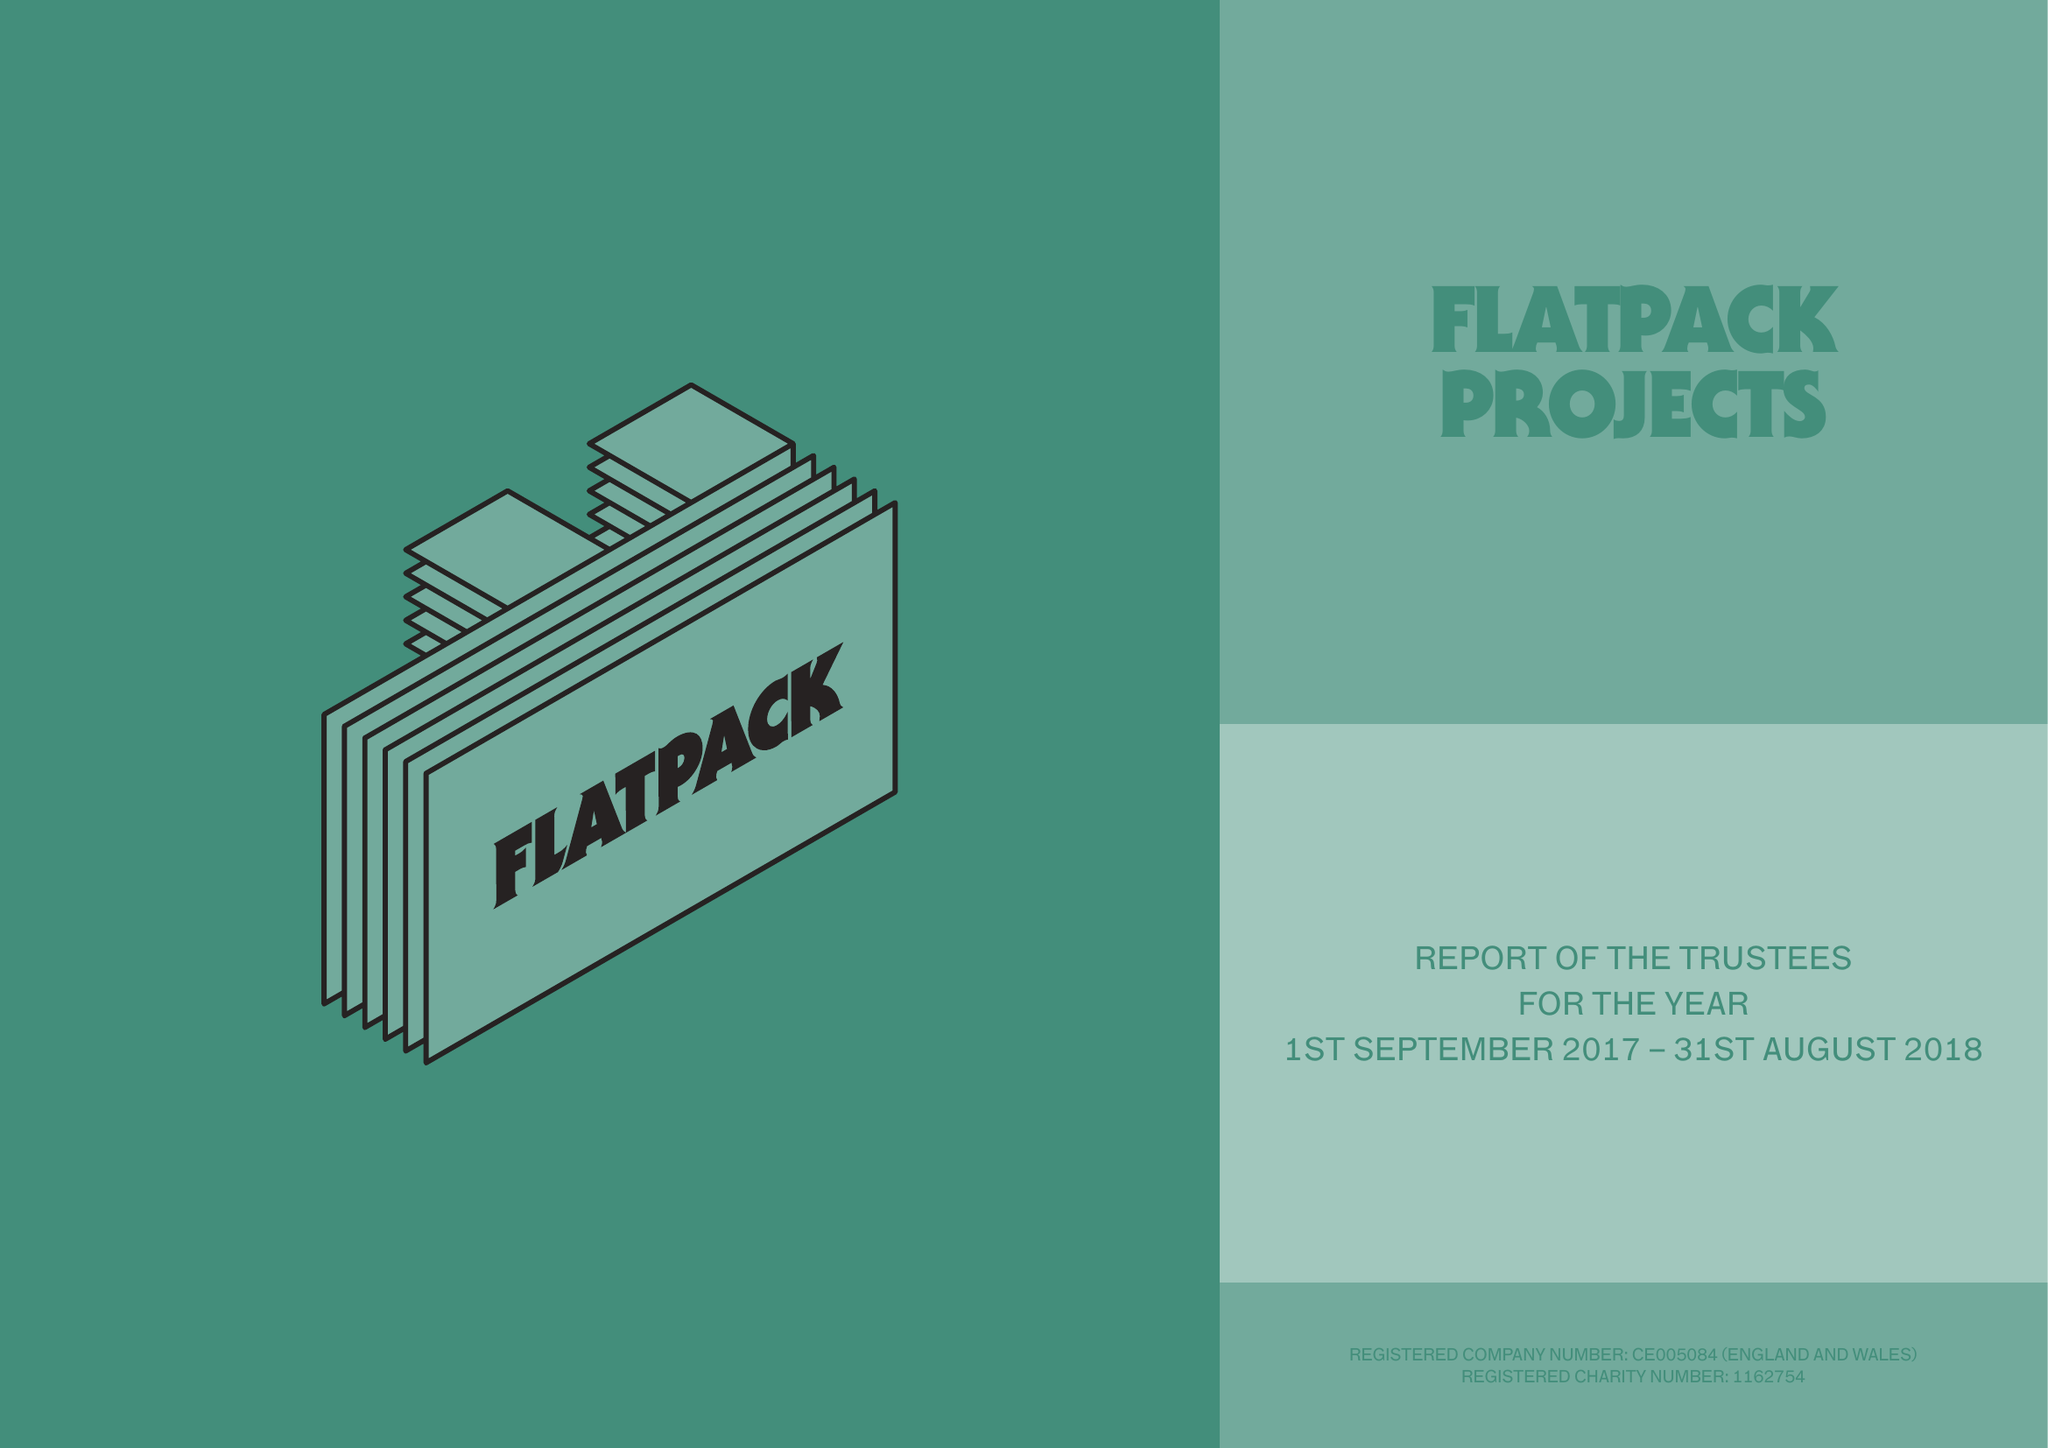What is the value for the charity_number?
Answer the question using a single word or phrase. 1162754 